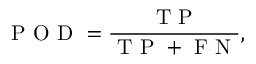Convert formula to latex. <formula><loc_0><loc_0><loc_500><loc_500>P O D = \frac { T P } { T P + F N } ,</formula> 